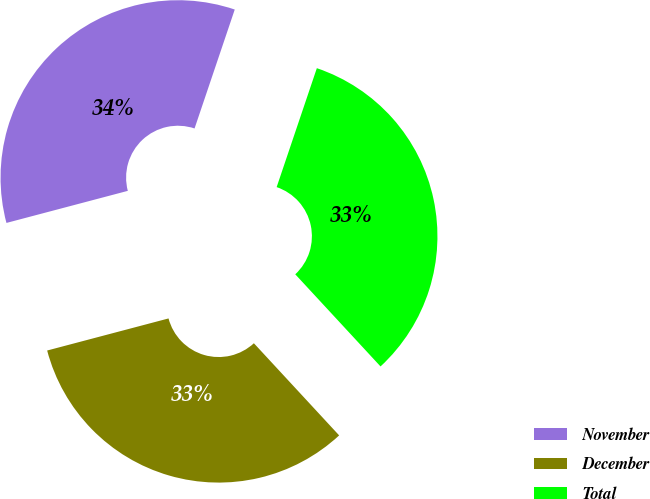Convert chart. <chart><loc_0><loc_0><loc_500><loc_500><pie_chart><fcel>November<fcel>December<fcel>Total<nl><fcel>34.3%<fcel>32.77%<fcel>32.93%<nl></chart> 